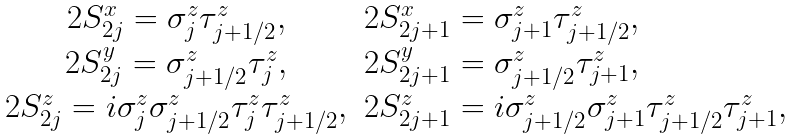Convert formula to latex. <formula><loc_0><loc_0><loc_500><loc_500>\begin{array} { c l c r } 2 S ^ { x } _ { 2 j } = \sigma ^ { z } _ { j } \tau ^ { z } _ { j + 1 / 2 } , & 2 S ^ { x } _ { 2 j + 1 } = \sigma ^ { z } _ { j + 1 } \tau ^ { z } _ { j + 1 / 2 } , \\ 2 S ^ { y } _ { 2 j } = \sigma ^ { z } _ { j + 1 / 2 } \tau ^ { z } _ { j } , & 2 S ^ { y } _ { 2 j + 1 } = \sigma ^ { z } _ { j + 1 / 2 } \tau ^ { z } _ { j + 1 } , \\ 2 S ^ { z } _ { 2 j } = i \sigma ^ { z } _ { j } \sigma ^ { z } _ { j + 1 / 2 } \tau ^ { z } _ { j } \tau ^ { z } _ { j + 1 / 2 } , & 2 S ^ { z } _ { 2 j + 1 } = i \sigma ^ { z } _ { j + 1 / 2 } \sigma ^ { z } _ { j + 1 } \tau ^ { z } _ { j + 1 / 2 } \tau ^ { z } _ { j + 1 } , \end{array}</formula> 